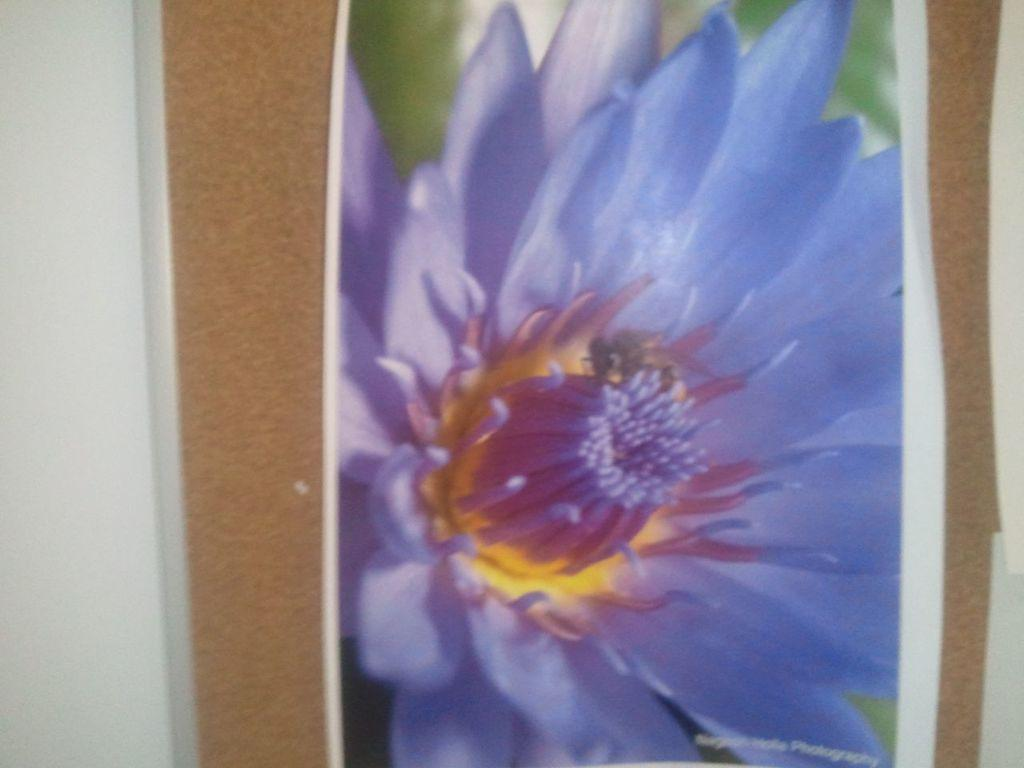What is the main object in the image? There is a board in the image. Where is the board located? The board is on a surface. What is depicted on the board? There is a photo of a flower on the board. What type of boot is being worn by the laborer in the image? There is no laborer or boot present in the image; it only features a board with a photo of a flower. 